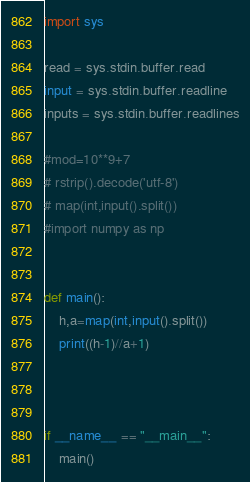Convert code to text. <code><loc_0><loc_0><loc_500><loc_500><_Python_>import sys

read = sys.stdin.buffer.read
input = sys.stdin.buffer.readline
inputs = sys.stdin.buffer.readlines

#mod=10**9+7
# rstrip().decode('utf-8')
# map(int,input().split())
#import numpy as np


def main():
	h,a=map(int,input().split())
	print((h-1)//a+1)
	
	

if __name__ == "__main__":
	main()
</code> 